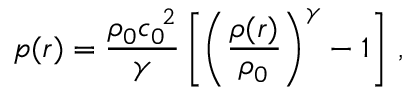<formula> <loc_0><loc_0><loc_500><loc_500>p ( r ) = \frac { \rho _ { 0 } { c _ { 0 } } ^ { \, 2 } } { \gamma } \left [ \left ( \frac { \rho ( r ) } { \rho _ { 0 } } \right ) ^ { \gamma } - 1 \right ] \, ,</formula> 